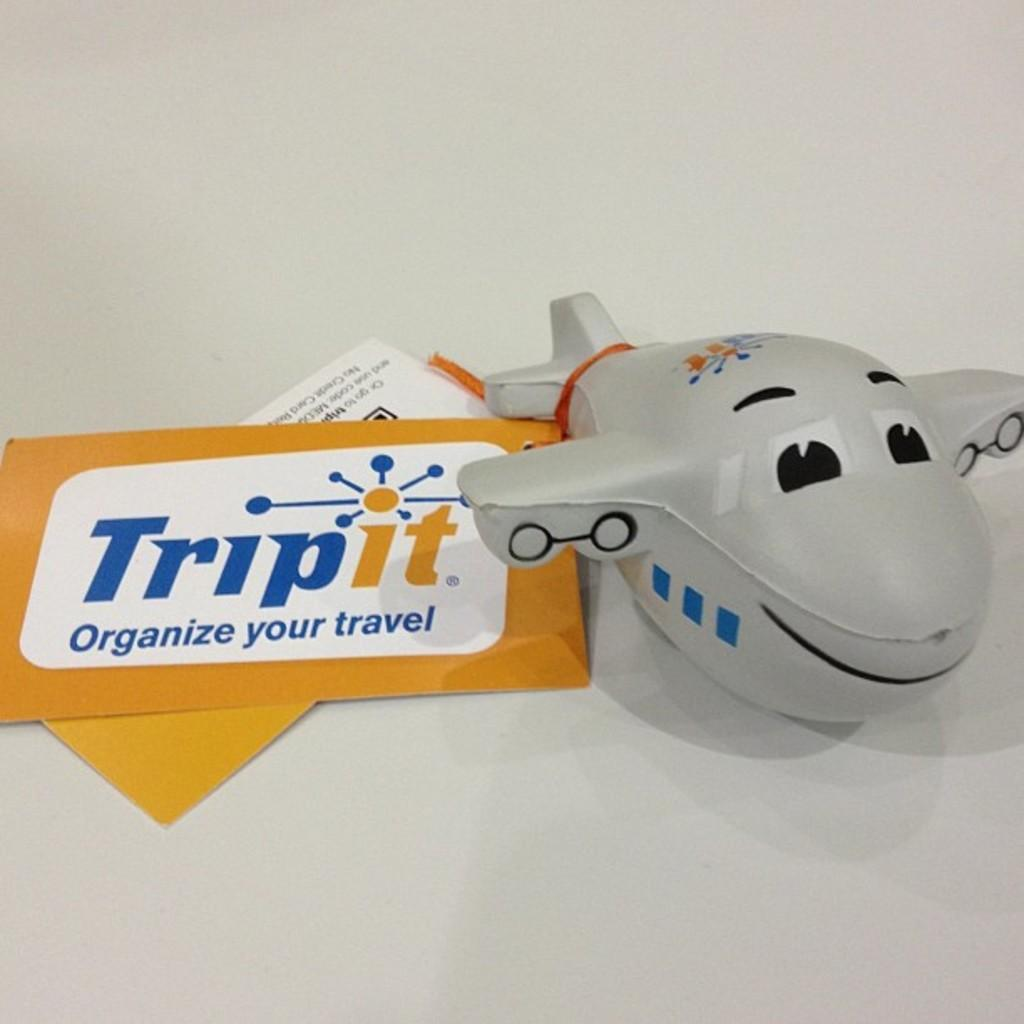<image>
Offer a succinct explanation of the picture presented. Using Tripit can help you organize your travel. 